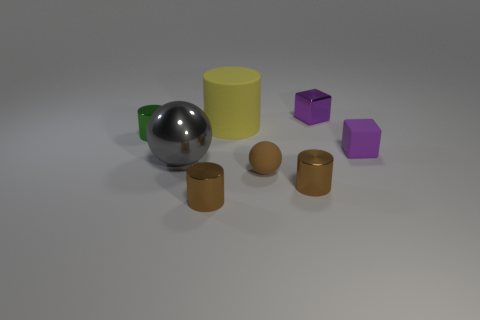Add 1 yellow cylinders. How many objects exist? 9 Subtract all green cylinders. How many gray cubes are left? 0 Subtract all purple metallic blocks. Subtract all tiny purple matte cylinders. How many objects are left? 7 Add 1 gray shiny spheres. How many gray shiny spheres are left? 2 Add 7 shiny cylinders. How many shiny cylinders exist? 10 Subtract all gray spheres. How many spheres are left? 1 Subtract all tiny cylinders. How many cylinders are left? 1 Subtract 0 yellow balls. How many objects are left? 8 Subtract all spheres. How many objects are left? 6 Subtract 1 balls. How many balls are left? 1 